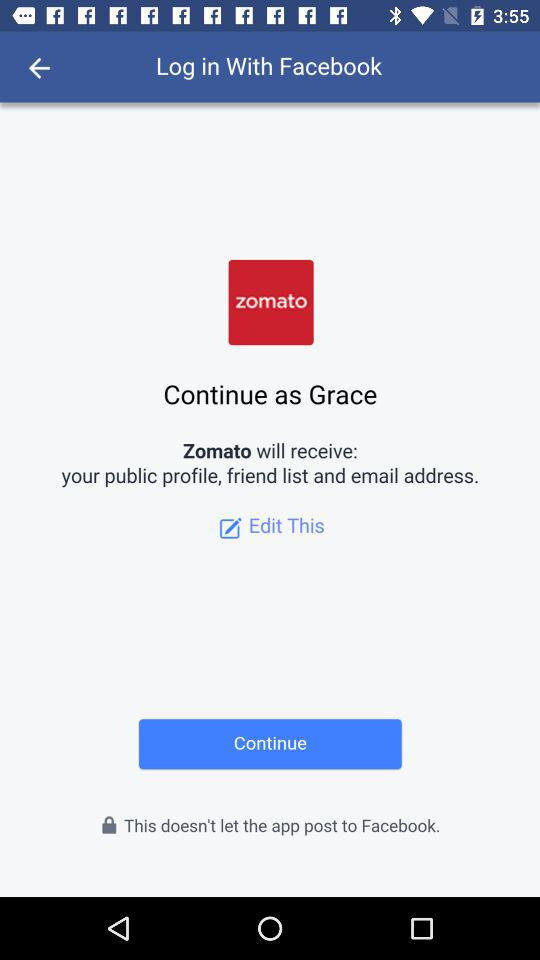"Zomato" is developed by who?
When the provided information is insufficient, respond with <no answer>. <no answer> 